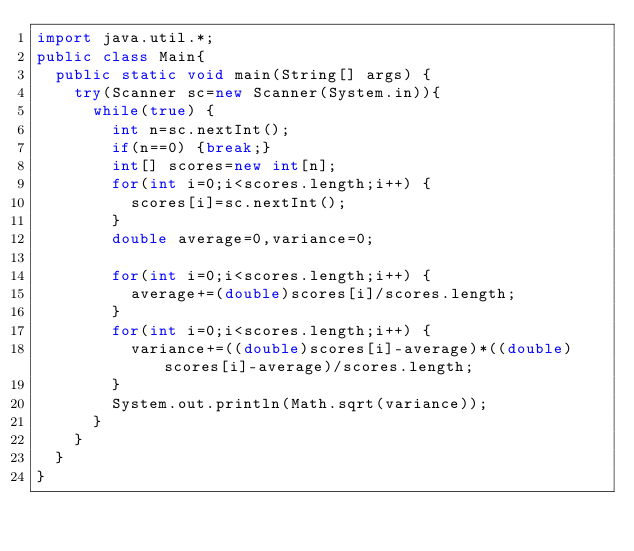<code> <loc_0><loc_0><loc_500><loc_500><_Java_>import java.util.*;
public class Main{
	public static void main(String[] args) {
		try(Scanner sc=new Scanner(System.in)){
			while(true) {
				int n=sc.nextInt();
				if(n==0) {break;}
				int[] scores=new int[n];
				for(int i=0;i<scores.length;i++) {
					scores[i]=sc.nextInt();
				}
				double average=0,variance=0;
				
				for(int i=0;i<scores.length;i++) {
					average+=(double)scores[i]/scores.length;
				}
				for(int i=0;i<scores.length;i++) {
					variance+=((double)scores[i]-average)*((double)scores[i]-average)/scores.length;
				}
				System.out.println(Math.sqrt(variance));
			}
		}
	}
}
</code> 